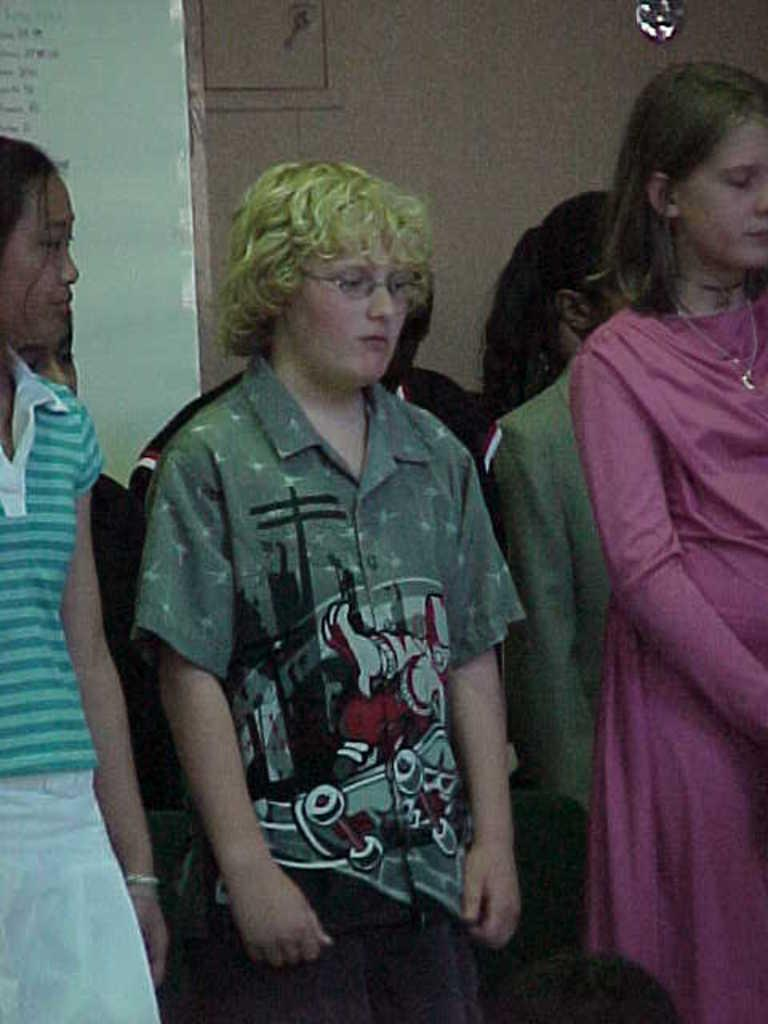What can be seen in the image? There are persons standing in the image. What is visible in the background of the image? There is a board, a wall, and an object in the background of the image. What might the persons be using to sit down? Chairs are present at the bottom of the image. Can you tell me how many tickets the parent is holding in the image? There is no parent or ticket present in the image. What type of object is the person trying to join in the image? There is no object or person trying to join anything in the image. 